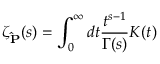Convert formula to latex. <formula><loc_0><loc_0><loc_500><loc_500>\zeta _ { \hat { P } } ( s ) = \int _ { 0 } ^ { \infty } d t \frac { t ^ { s - 1 } } { \Gamma ( s ) } K ( t )</formula> 